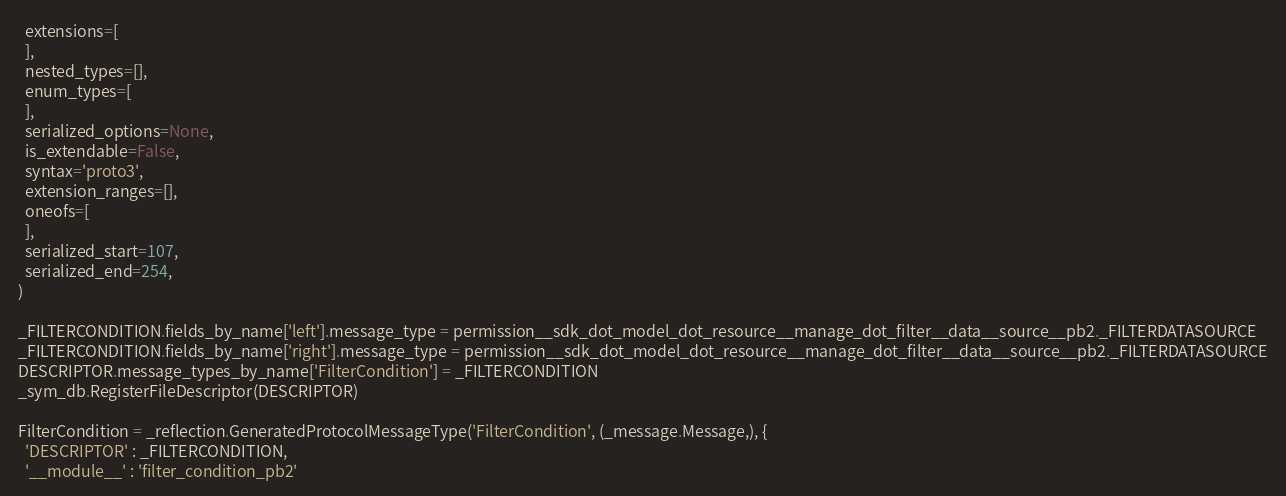Convert code to text. <code><loc_0><loc_0><loc_500><loc_500><_Python_>  extensions=[
  ],
  nested_types=[],
  enum_types=[
  ],
  serialized_options=None,
  is_extendable=False,
  syntax='proto3',
  extension_ranges=[],
  oneofs=[
  ],
  serialized_start=107,
  serialized_end=254,
)

_FILTERCONDITION.fields_by_name['left'].message_type = permission__sdk_dot_model_dot_resource__manage_dot_filter__data__source__pb2._FILTERDATASOURCE
_FILTERCONDITION.fields_by_name['right'].message_type = permission__sdk_dot_model_dot_resource__manage_dot_filter__data__source__pb2._FILTERDATASOURCE
DESCRIPTOR.message_types_by_name['FilterCondition'] = _FILTERCONDITION
_sym_db.RegisterFileDescriptor(DESCRIPTOR)

FilterCondition = _reflection.GeneratedProtocolMessageType('FilterCondition', (_message.Message,), {
  'DESCRIPTOR' : _FILTERCONDITION,
  '__module__' : 'filter_condition_pb2'</code> 